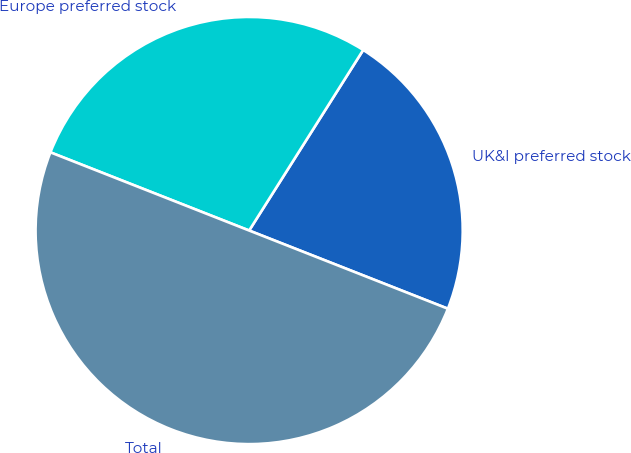Convert chart. <chart><loc_0><loc_0><loc_500><loc_500><pie_chart><fcel>UK&I preferred stock<fcel>Europe preferred stock<fcel>Total<nl><fcel>22.0%<fcel>28.0%<fcel>50.0%<nl></chart> 